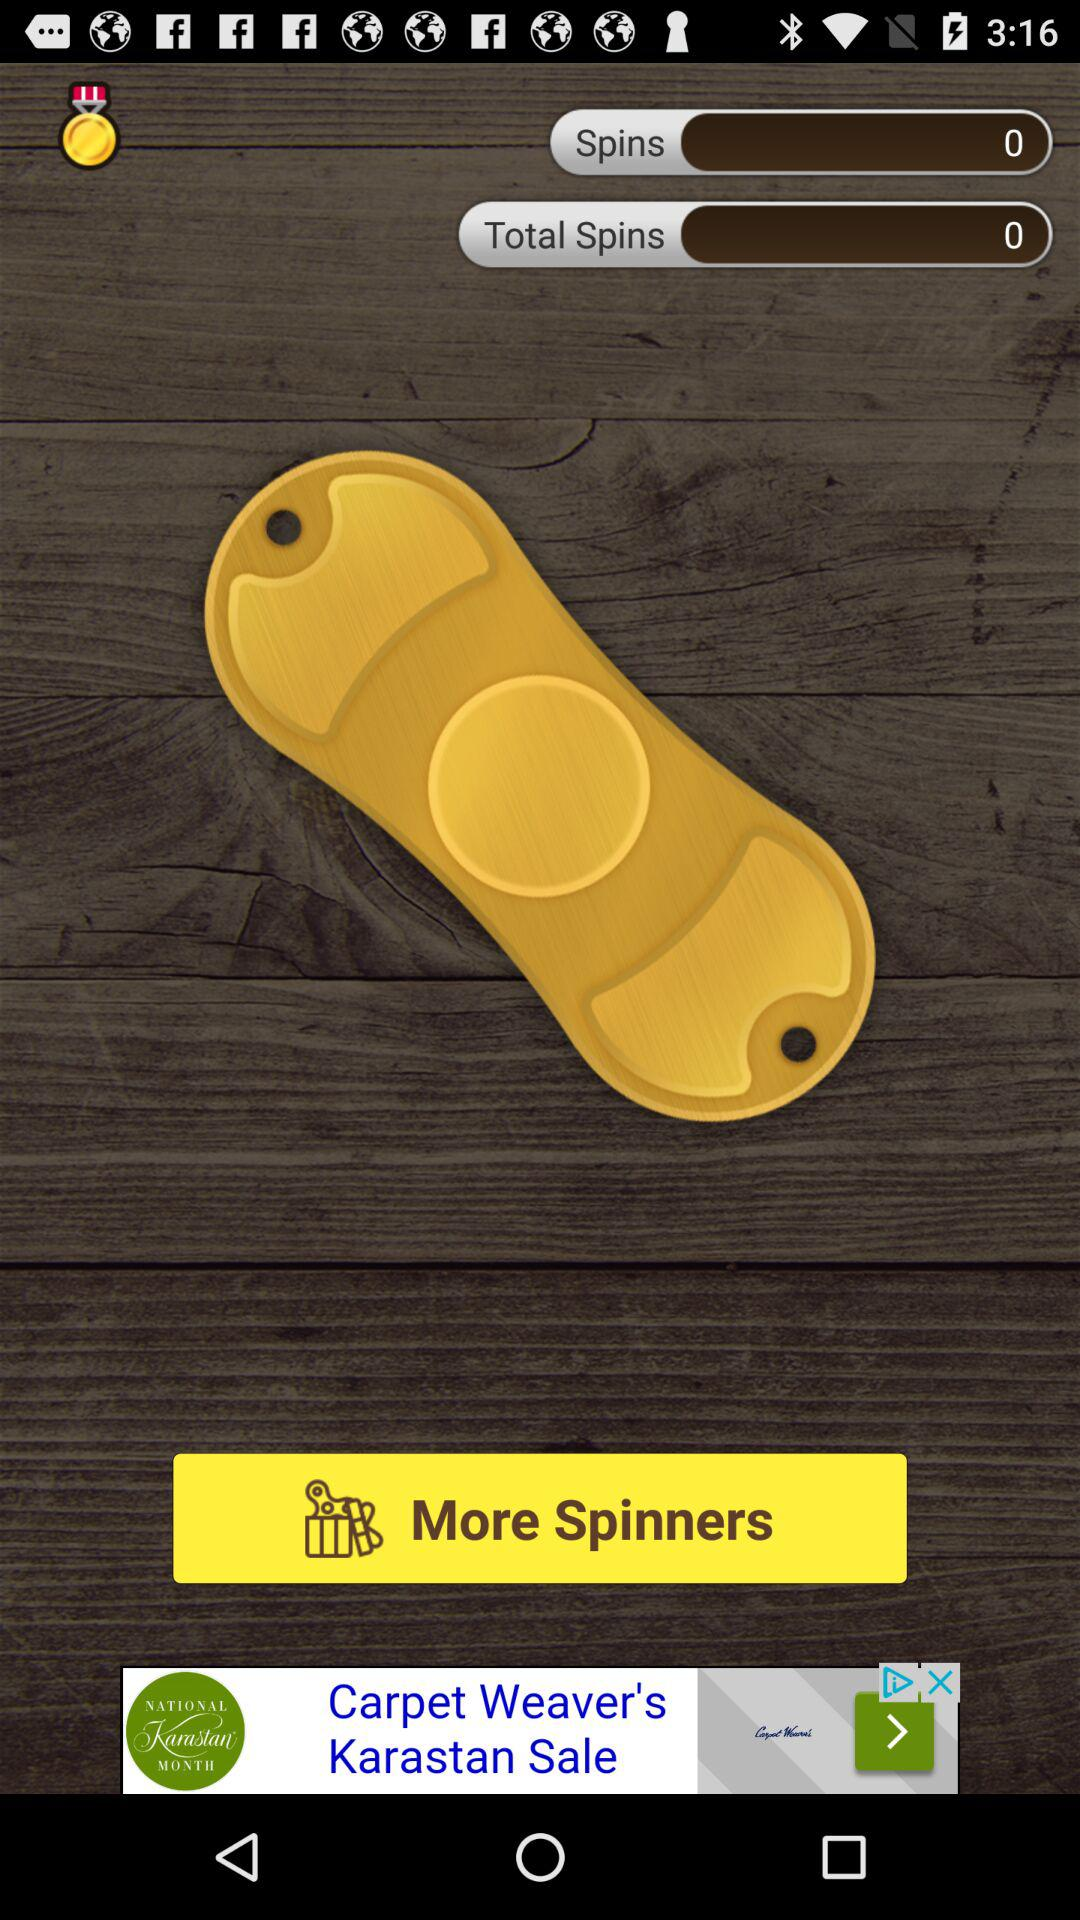What is the count of spins? The count of spins is 0. 